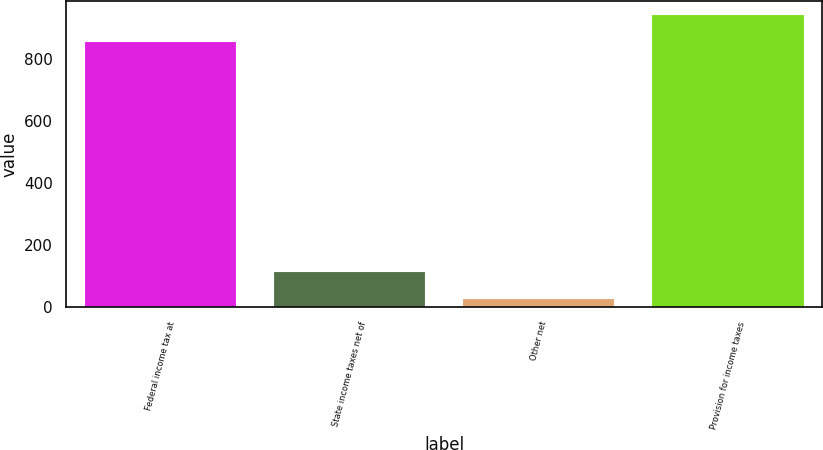Convert chart. <chart><loc_0><loc_0><loc_500><loc_500><bar_chart><fcel>Federal income tax at<fcel>State income taxes net of<fcel>Other net<fcel>Provision for income taxes<nl><fcel>855<fcel>112.9<fcel>27<fcel>940.9<nl></chart> 